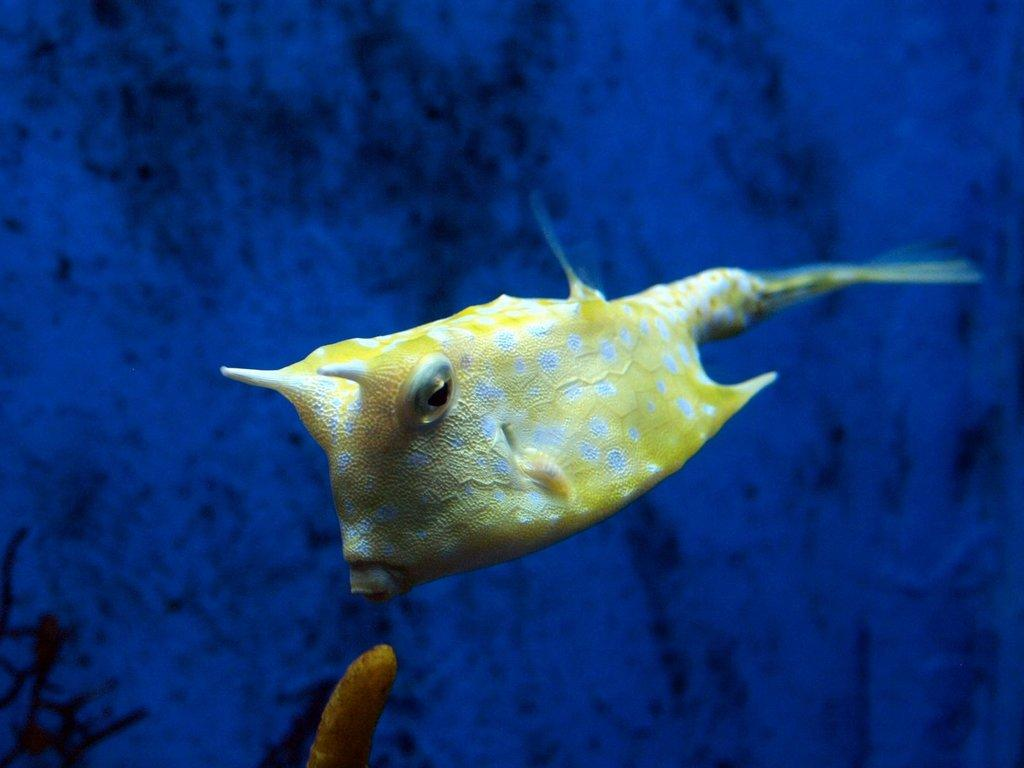What type of animal is in the image? There is a yellow color fish in the image. Where is the fish located? The fish is in the water. What color is the background of the image? The background of the image is blue. Can you see any smoke coming from the fish in the image? There is no smoke present in the image; it features a yellow color fish in the water. What type of carriage is visible in the image? There is no carriage present in the image. 